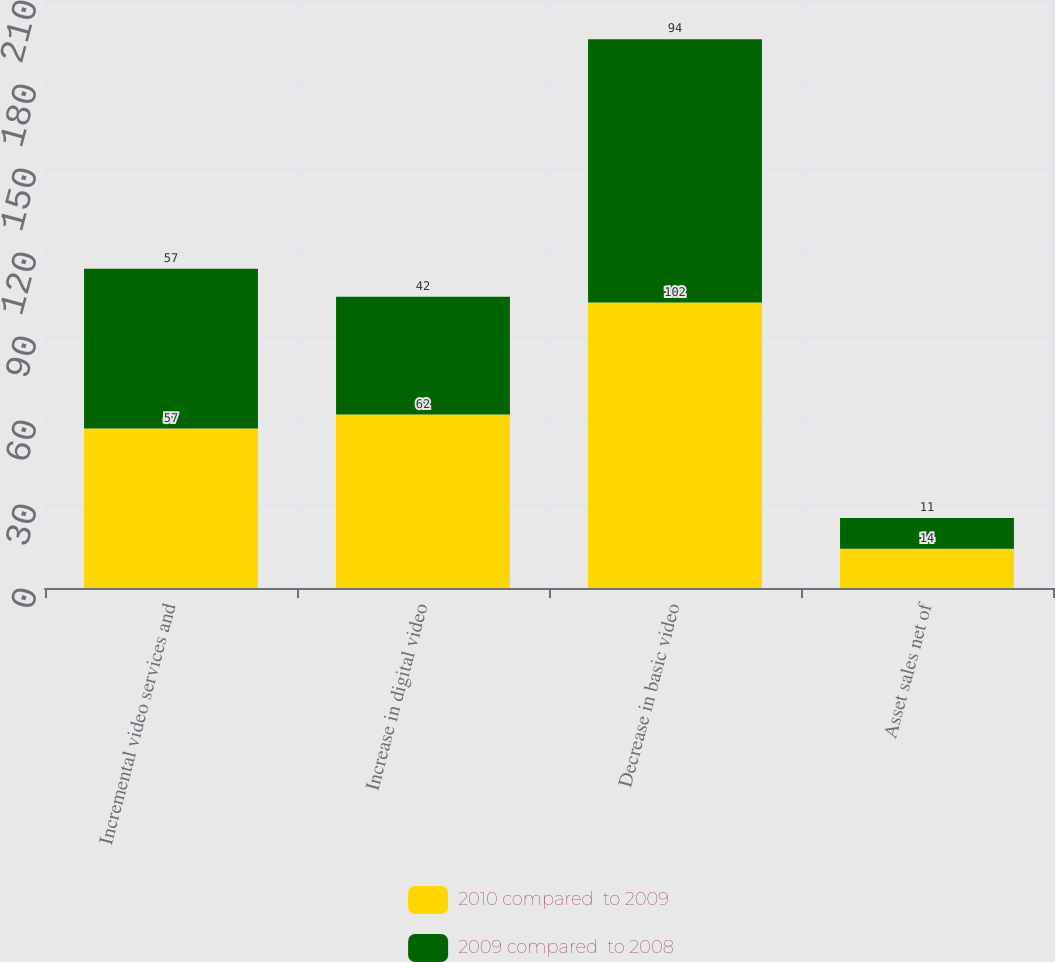Convert chart. <chart><loc_0><loc_0><loc_500><loc_500><stacked_bar_chart><ecel><fcel>Incremental video services and<fcel>Increase in digital video<fcel>Decrease in basic video<fcel>Asset sales net of<nl><fcel>2010 compared  to 2009<fcel>57<fcel>62<fcel>102<fcel>14<nl><fcel>2009 compared  to 2008<fcel>57<fcel>42<fcel>94<fcel>11<nl></chart> 